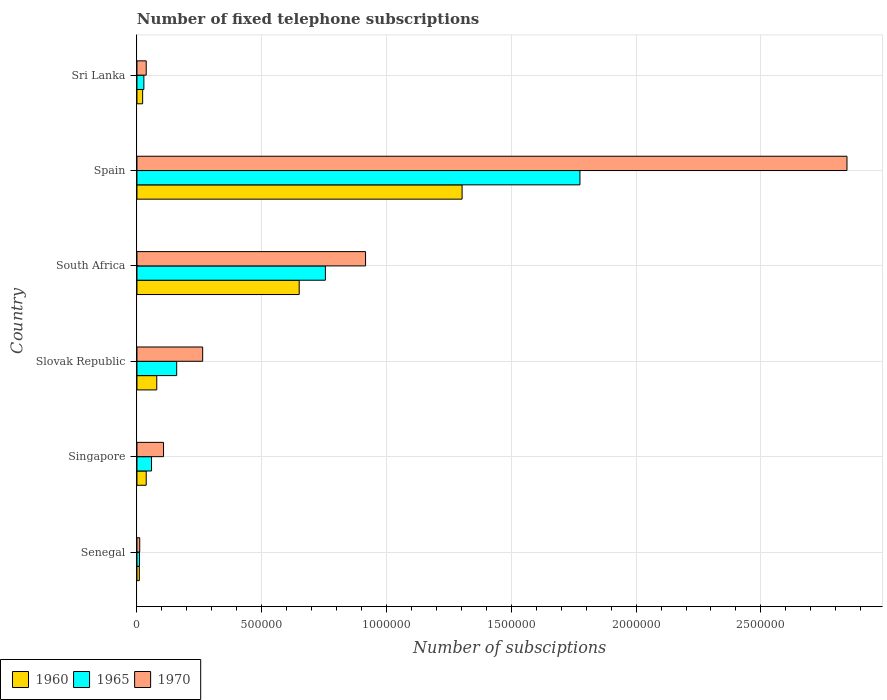How many different coloured bars are there?
Provide a succinct answer. 3. How many bars are there on the 3rd tick from the bottom?
Offer a very short reply. 3. What is the label of the 5th group of bars from the top?
Give a very brief answer. Singapore. What is the number of fixed telephone subscriptions in 1965 in Sri Lanka?
Provide a succinct answer. 2.77e+04. Across all countries, what is the maximum number of fixed telephone subscriptions in 1970?
Give a very brief answer. 2.84e+06. Across all countries, what is the minimum number of fixed telephone subscriptions in 1970?
Your answer should be compact. 1.10e+04. In which country was the number of fixed telephone subscriptions in 1960 minimum?
Give a very brief answer. Senegal. What is the total number of fixed telephone subscriptions in 1960 in the graph?
Ensure brevity in your answer.  2.10e+06. What is the difference between the number of fixed telephone subscriptions in 1970 in Singapore and that in Spain?
Ensure brevity in your answer.  -2.74e+06. What is the difference between the number of fixed telephone subscriptions in 1960 in Slovak Republic and the number of fixed telephone subscriptions in 1965 in Senegal?
Your answer should be very brief. 6.93e+04. What is the average number of fixed telephone subscriptions in 1965 per country?
Make the answer very short. 4.64e+05. What is the difference between the number of fixed telephone subscriptions in 1965 and number of fixed telephone subscriptions in 1970 in Slovak Republic?
Provide a short and direct response. -1.04e+05. What is the ratio of the number of fixed telephone subscriptions in 1970 in Singapore to that in Sri Lanka?
Ensure brevity in your answer.  2.87. Is the difference between the number of fixed telephone subscriptions in 1965 in South Africa and Sri Lanka greater than the difference between the number of fixed telephone subscriptions in 1970 in South Africa and Sri Lanka?
Provide a succinct answer. No. What is the difference between the highest and the second highest number of fixed telephone subscriptions in 1965?
Provide a short and direct response. 1.02e+06. What is the difference between the highest and the lowest number of fixed telephone subscriptions in 1960?
Your response must be concise. 1.29e+06. What does the 3rd bar from the top in Sri Lanka represents?
Offer a terse response. 1960. What does the 2nd bar from the bottom in Senegal represents?
Provide a short and direct response. 1965. How many countries are there in the graph?
Your response must be concise. 6. Does the graph contain any zero values?
Provide a succinct answer. No. Does the graph contain grids?
Offer a terse response. Yes. How many legend labels are there?
Your answer should be compact. 3. What is the title of the graph?
Offer a very short reply. Number of fixed telephone subscriptions. What is the label or title of the X-axis?
Offer a very short reply. Number of subsciptions. What is the label or title of the Y-axis?
Ensure brevity in your answer.  Country. What is the Number of subsciptions of 1960 in Senegal?
Give a very brief answer. 9494. What is the Number of subsciptions of 1965 in Senegal?
Your response must be concise. 10000. What is the Number of subsciptions in 1970 in Senegal?
Offer a terse response. 1.10e+04. What is the Number of subsciptions in 1960 in Singapore?
Your answer should be very brief. 3.71e+04. What is the Number of subsciptions in 1965 in Singapore?
Provide a short and direct response. 5.84e+04. What is the Number of subsciptions in 1970 in Singapore?
Offer a terse response. 1.06e+05. What is the Number of subsciptions in 1960 in Slovak Republic?
Give a very brief answer. 7.93e+04. What is the Number of subsciptions of 1965 in Slovak Republic?
Offer a terse response. 1.59e+05. What is the Number of subsciptions of 1970 in Slovak Republic?
Your answer should be compact. 2.63e+05. What is the Number of subsciptions of 1960 in South Africa?
Keep it short and to the point. 6.50e+05. What is the Number of subsciptions in 1965 in South Africa?
Ensure brevity in your answer.  7.55e+05. What is the Number of subsciptions of 1970 in South Africa?
Make the answer very short. 9.16e+05. What is the Number of subsciptions of 1960 in Spain?
Offer a very short reply. 1.30e+06. What is the Number of subsciptions in 1965 in Spain?
Ensure brevity in your answer.  1.78e+06. What is the Number of subsciptions of 1970 in Spain?
Make the answer very short. 2.84e+06. What is the Number of subsciptions of 1960 in Sri Lanka?
Provide a short and direct response. 2.28e+04. What is the Number of subsciptions of 1965 in Sri Lanka?
Make the answer very short. 2.77e+04. What is the Number of subsciptions in 1970 in Sri Lanka?
Ensure brevity in your answer.  3.71e+04. Across all countries, what is the maximum Number of subsciptions in 1960?
Make the answer very short. 1.30e+06. Across all countries, what is the maximum Number of subsciptions in 1965?
Your response must be concise. 1.78e+06. Across all countries, what is the maximum Number of subsciptions of 1970?
Your answer should be very brief. 2.84e+06. Across all countries, what is the minimum Number of subsciptions of 1960?
Your answer should be compact. 9494. Across all countries, what is the minimum Number of subsciptions of 1965?
Keep it short and to the point. 10000. Across all countries, what is the minimum Number of subsciptions in 1970?
Offer a terse response. 1.10e+04. What is the total Number of subsciptions in 1960 in the graph?
Offer a very short reply. 2.10e+06. What is the total Number of subsciptions in 1965 in the graph?
Your answer should be compact. 2.79e+06. What is the total Number of subsciptions in 1970 in the graph?
Make the answer very short. 4.18e+06. What is the difference between the Number of subsciptions of 1960 in Senegal and that in Singapore?
Make the answer very short. -2.76e+04. What is the difference between the Number of subsciptions of 1965 in Senegal and that in Singapore?
Offer a very short reply. -4.84e+04. What is the difference between the Number of subsciptions in 1970 in Senegal and that in Singapore?
Give a very brief answer. -9.54e+04. What is the difference between the Number of subsciptions of 1960 in Senegal and that in Slovak Republic?
Your answer should be very brief. -6.98e+04. What is the difference between the Number of subsciptions in 1965 in Senegal and that in Slovak Republic?
Give a very brief answer. -1.49e+05. What is the difference between the Number of subsciptions of 1970 in Senegal and that in Slovak Republic?
Your answer should be very brief. -2.52e+05. What is the difference between the Number of subsciptions of 1960 in Senegal and that in South Africa?
Give a very brief answer. -6.41e+05. What is the difference between the Number of subsciptions of 1965 in Senegal and that in South Africa?
Your answer should be compact. -7.45e+05. What is the difference between the Number of subsciptions of 1970 in Senegal and that in South Africa?
Provide a short and direct response. -9.05e+05. What is the difference between the Number of subsciptions in 1960 in Senegal and that in Spain?
Your response must be concise. -1.29e+06. What is the difference between the Number of subsciptions in 1965 in Senegal and that in Spain?
Offer a terse response. -1.76e+06. What is the difference between the Number of subsciptions of 1970 in Senegal and that in Spain?
Provide a short and direct response. -2.83e+06. What is the difference between the Number of subsciptions in 1960 in Senegal and that in Sri Lanka?
Give a very brief answer. -1.33e+04. What is the difference between the Number of subsciptions of 1965 in Senegal and that in Sri Lanka?
Your answer should be compact. -1.77e+04. What is the difference between the Number of subsciptions of 1970 in Senegal and that in Sri Lanka?
Provide a succinct answer. -2.61e+04. What is the difference between the Number of subsciptions in 1960 in Singapore and that in Slovak Republic?
Provide a succinct answer. -4.22e+04. What is the difference between the Number of subsciptions in 1965 in Singapore and that in Slovak Republic?
Offer a terse response. -1.01e+05. What is the difference between the Number of subsciptions of 1970 in Singapore and that in Slovak Republic?
Provide a succinct answer. -1.57e+05. What is the difference between the Number of subsciptions of 1960 in Singapore and that in South Africa?
Keep it short and to the point. -6.13e+05. What is the difference between the Number of subsciptions of 1965 in Singapore and that in South Africa?
Offer a terse response. -6.97e+05. What is the difference between the Number of subsciptions of 1970 in Singapore and that in South Africa?
Your answer should be very brief. -8.10e+05. What is the difference between the Number of subsciptions of 1960 in Singapore and that in Spain?
Provide a short and direct response. -1.27e+06. What is the difference between the Number of subsciptions in 1965 in Singapore and that in Spain?
Make the answer very short. -1.72e+06. What is the difference between the Number of subsciptions of 1970 in Singapore and that in Spain?
Provide a succinct answer. -2.74e+06. What is the difference between the Number of subsciptions of 1960 in Singapore and that in Sri Lanka?
Provide a succinct answer. 1.43e+04. What is the difference between the Number of subsciptions of 1965 in Singapore and that in Sri Lanka?
Keep it short and to the point. 3.07e+04. What is the difference between the Number of subsciptions in 1970 in Singapore and that in Sri Lanka?
Give a very brief answer. 6.93e+04. What is the difference between the Number of subsciptions of 1960 in Slovak Republic and that in South Africa?
Provide a short and direct response. -5.71e+05. What is the difference between the Number of subsciptions in 1965 in Slovak Republic and that in South Africa?
Your answer should be compact. -5.96e+05. What is the difference between the Number of subsciptions of 1970 in Slovak Republic and that in South Africa?
Your answer should be compact. -6.53e+05. What is the difference between the Number of subsciptions in 1960 in Slovak Republic and that in Spain?
Provide a succinct answer. -1.22e+06. What is the difference between the Number of subsciptions of 1965 in Slovak Republic and that in Spain?
Provide a succinct answer. -1.62e+06. What is the difference between the Number of subsciptions of 1970 in Slovak Republic and that in Spain?
Your answer should be compact. -2.58e+06. What is the difference between the Number of subsciptions of 1960 in Slovak Republic and that in Sri Lanka?
Ensure brevity in your answer.  5.66e+04. What is the difference between the Number of subsciptions in 1965 in Slovak Republic and that in Sri Lanka?
Your answer should be very brief. 1.32e+05. What is the difference between the Number of subsciptions in 1970 in Slovak Republic and that in Sri Lanka?
Offer a very short reply. 2.26e+05. What is the difference between the Number of subsciptions in 1960 in South Africa and that in Spain?
Ensure brevity in your answer.  -6.53e+05. What is the difference between the Number of subsciptions in 1965 in South Africa and that in Spain?
Your response must be concise. -1.02e+06. What is the difference between the Number of subsciptions in 1970 in South Africa and that in Spain?
Your response must be concise. -1.93e+06. What is the difference between the Number of subsciptions of 1960 in South Africa and that in Sri Lanka?
Your answer should be compact. 6.27e+05. What is the difference between the Number of subsciptions of 1965 in South Africa and that in Sri Lanka?
Your answer should be very brief. 7.27e+05. What is the difference between the Number of subsciptions in 1970 in South Africa and that in Sri Lanka?
Provide a succinct answer. 8.79e+05. What is the difference between the Number of subsciptions of 1960 in Spain and that in Sri Lanka?
Provide a succinct answer. 1.28e+06. What is the difference between the Number of subsciptions in 1965 in Spain and that in Sri Lanka?
Offer a very short reply. 1.75e+06. What is the difference between the Number of subsciptions of 1970 in Spain and that in Sri Lanka?
Your answer should be compact. 2.81e+06. What is the difference between the Number of subsciptions of 1960 in Senegal and the Number of subsciptions of 1965 in Singapore?
Your answer should be compact. -4.89e+04. What is the difference between the Number of subsciptions in 1960 in Senegal and the Number of subsciptions in 1970 in Singapore?
Give a very brief answer. -9.69e+04. What is the difference between the Number of subsciptions of 1965 in Senegal and the Number of subsciptions of 1970 in Singapore?
Make the answer very short. -9.64e+04. What is the difference between the Number of subsciptions in 1960 in Senegal and the Number of subsciptions in 1965 in Slovak Republic?
Provide a succinct answer. -1.50e+05. What is the difference between the Number of subsciptions in 1960 in Senegal and the Number of subsciptions in 1970 in Slovak Republic?
Keep it short and to the point. -2.54e+05. What is the difference between the Number of subsciptions of 1965 in Senegal and the Number of subsciptions of 1970 in Slovak Republic?
Your answer should be very brief. -2.53e+05. What is the difference between the Number of subsciptions in 1960 in Senegal and the Number of subsciptions in 1965 in South Africa?
Ensure brevity in your answer.  -7.46e+05. What is the difference between the Number of subsciptions of 1960 in Senegal and the Number of subsciptions of 1970 in South Africa?
Your answer should be compact. -9.07e+05. What is the difference between the Number of subsciptions in 1965 in Senegal and the Number of subsciptions in 1970 in South Africa?
Provide a short and direct response. -9.06e+05. What is the difference between the Number of subsciptions in 1960 in Senegal and the Number of subsciptions in 1965 in Spain?
Your answer should be compact. -1.77e+06. What is the difference between the Number of subsciptions in 1960 in Senegal and the Number of subsciptions in 1970 in Spain?
Provide a succinct answer. -2.84e+06. What is the difference between the Number of subsciptions of 1965 in Senegal and the Number of subsciptions of 1970 in Spain?
Provide a succinct answer. -2.84e+06. What is the difference between the Number of subsciptions of 1960 in Senegal and the Number of subsciptions of 1965 in Sri Lanka?
Your response must be concise. -1.82e+04. What is the difference between the Number of subsciptions of 1960 in Senegal and the Number of subsciptions of 1970 in Sri Lanka?
Your response must be concise. -2.76e+04. What is the difference between the Number of subsciptions of 1965 in Senegal and the Number of subsciptions of 1970 in Sri Lanka?
Your answer should be compact. -2.71e+04. What is the difference between the Number of subsciptions of 1960 in Singapore and the Number of subsciptions of 1965 in Slovak Republic?
Give a very brief answer. -1.22e+05. What is the difference between the Number of subsciptions in 1960 in Singapore and the Number of subsciptions in 1970 in Slovak Republic?
Keep it short and to the point. -2.26e+05. What is the difference between the Number of subsciptions in 1965 in Singapore and the Number of subsciptions in 1970 in Slovak Republic?
Provide a short and direct response. -2.05e+05. What is the difference between the Number of subsciptions in 1960 in Singapore and the Number of subsciptions in 1965 in South Africa?
Offer a very short reply. -7.18e+05. What is the difference between the Number of subsciptions of 1960 in Singapore and the Number of subsciptions of 1970 in South Africa?
Your answer should be compact. -8.79e+05. What is the difference between the Number of subsciptions of 1965 in Singapore and the Number of subsciptions of 1970 in South Africa?
Your answer should be very brief. -8.58e+05. What is the difference between the Number of subsciptions in 1960 in Singapore and the Number of subsciptions in 1965 in Spain?
Ensure brevity in your answer.  -1.74e+06. What is the difference between the Number of subsciptions of 1960 in Singapore and the Number of subsciptions of 1970 in Spain?
Provide a succinct answer. -2.81e+06. What is the difference between the Number of subsciptions of 1965 in Singapore and the Number of subsciptions of 1970 in Spain?
Your answer should be compact. -2.79e+06. What is the difference between the Number of subsciptions of 1960 in Singapore and the Number of subsciptions of 1965 in Sri Lanka?
Provide a succinct answer. 9413. What is the difference between the Number of subsciptions of 1960 in Singapore and the Number of subsciptions of 1970 in Sri Lanka?
Your response must be concise. 13. What is the difference between the Number of subsciptions in 1965 in Singapore and the Number of subsciptions in 1970 in Sri Lanka?
Provide a succinct answer. 2.13e+04. What is the difference between the Number of subsciptions in 1960 in Slovak Republic and the Number of subsciptions in 1965 in South Africa?
Keep it short and to the point. -6.76e+05. What is the difference between the Number of subsciptions in 1960 in Slovak Republic and the Number of subsciptions in 1970 in South Africa?
Keep it short and to the point. -8.37e+05. What is the difference between the Number of subsciptions of 1965 in Slovak Republic and the Number of subsciptions of 1970 in South Africa?
Offer a very short reply. -7.57e+05. What is the difference between the Number of subsciptions in 1960 in Slovak Republic and the Number of subsciptions in 1965 in Spain?
Ensure brevity in your answer.  -1.70e+06. What is the difference between the Number of subsciptions in 1960 in Slovak Republic and the Number of subsciptions in 1970 in Spain?
Offer a very short reply. -2.77e+06. What is the difference between the Number of subsciptions in 1965 in Slovak Republic and the Number of subsciptions in 1970 in Spain?
Ensure brevity in your answer.  -2.69e+06. What is the difference between the Number of subsciptions in 1960 in Slovak Republic and the Number of subsciptions in 1965 in Sri Lanka?
Ensure brevity in your answer.  5.16e+04. What is the difference between the Number of subsciptions in 1960 in Slovak Republic and the Number of subsciptions in 1970 in Sri Lanka?
Give a very brief answer. 4.22e+04. What is the difference between the Number of subsciptions of 1965 in Slovak Republic and the Number of subsciptions of 1970 in Sri Lanka?
Provide a succinct answer. 1.22e+05. What is the difference between the Number of subsciptions of 1960 in South Africa and the Number of subsciptions of 1965 in Spain?
Provide a short and direct response. -1.12e+06. What is the difference between the Number of subsciptions of 1960 in South Africa and the Number of subsciptions of 1970 in Spain?
Your answer should be very brief. -2.19e+06. What is the difference between the Number of subsciptions in 1965 in South Africa and the Number of subsciptions in 1970 in Spain?
Give a very brief answer. -2.09e+06. What is the difference between the Number of subsciptions of 1960 in South Africa and the Number of subsciptions of 1965 in Sri Lanka?
Make the answer very short. 6.22e+05. What is the difference between the Number of subsciptions of 1960 in South Africa and the Number of subsciptions of 1970 in Sri Lanka?
Your answer should be very brief. 6.13e+05. What is the difference between the Number of subsciptions in 1965 in South Africa and the Number of subsciptions in 1970 in Sri Lanka?
Give a very brief answer. 7.18e+05. What is the difference between the Number of subsciptions in 1960 in Spain and the Number of subsciptions in 1965 in Sri Lanka?
Ensure brevity in your answer.  1.28e+06. What is the difference between the Number of subsciptions of 1960 in Spain and the Number of subsciptions of 1970 in Sri Lanka?
Provide a short and direct response. 1.27e+06. What is the difference between the Number of subsciptions in 1965 in Spain and the Number of subsciptions in 1970 in Sri Lanka?
Offer a terse response. 1.74e+06. What is the average Number of subsciptions in 1960 per country?
Your answer should be very brief. 3.50e+05. What is the average Number of subsciptions in 1965 per country?
Your response must be concise. 4.64e+05. What is the average Number of subsciptions of 1970 per country?
Provide a short and direct response. 6.96e+05. What is the difference between the Number of subsciptions of 1960 and Number of subsciptions of 1965 in Senegal?
Offer a very short reply. -506. What is the difference between the Number of subsciptions in 1960 and Number of subsciptions in 1970 in Senegal?
Provide a short and direct response. -1544. What is the difference between the Number of subsciptions in 1965 and Number of subsciptions in 1970 in Senegal?
Provide a succinct answer. -1038. What is the difference between the Number of subsciptions in 1960 and Number of subsciptions in 1965 in Singapore?
Ensure brevity in your answer.  -2.13e+04. What is the difference between the Number of subsciptions of 1960 and Number of subsciptions of 1970 in Singapore?
Provide a short and direct response. -6.93e+04. What is the difference between the Number of subsciptions of 1965 and Number of subsciptions of 1970 in Singapore?
Provide a succinct answer. -4.81e+04. What is the difference between the Number of subsciptions in 1960 and Number of subsciptions in 1965 in Slovak Republic?
Give a very brief answer. -7.99e+04. What is the difference between the Number of subsciptions of 1960 and Number of subsciptions of 1970 in Slovak Republic?
Ensure brevity in your answer.  -1.84e+05. What is the difference between the Number of subsciptions in 1965 and Number of subsciptions in 1970 in Slovak Republic?
Keep it short and to the point. -1.04e+05. What is the difference between the Number of subsciptions in 1960 and Number of subsciptions in 1965 in South Africa?
Provide a succinct answer. -1.05e+05. What is the difference between the Number of subsciptions in 1960 and Number of subsciptions in 1970 in South Africa?
Provide a short and direct response. -2.66e+05. What is the difference between the Number of subsciptions of 1965 and Number of subsciptions of 1970 in South Africa?
Make the answer very short. -1.61e+05. What is the difference between the Number of subsciptions of 1960 and Number of subsciptions of 1965 in Spain?
Give a very brief answer. -4.72e+05. What is the difference between the Number of subsciptions in 1960 and Number of subsciptions in 1970 in Spain?
Give a very brief answer. -1.54e+06. What is the difference between the Number of subsciptions in 1965 and Number of subsciptions in 1970 in Spain?
Your response must be concise. -1.07e+06. What is the difference between the Number of subsciptions of 1960 and Number of subsciptions of 1965 in Sri Lanka?
Provide a short and direct response. -4928. What is the difference between the Number of subsciptions of 1960 and Number of subsciptions of 1970 in Sri Lanka?
Make the answer very short. -1.43e+04. What is the difference between the Number of subsciptions of 1965 and Number of subsciptions of 1970 in Sri Lanka?
Ensure brevity in your answer.  -9400. What is the ratio of the Number of subsciptions of 1960 in Senegal to that in Singapore?
Give a very brief answer. 0.26. What is the ratio of the Number of subsciptions of 1965 in Senegal to that in Singapore?
Provide a short and direct response. 0.17. What is the ratio of the Number of subsciptions in 1970 in Senegal to that in Singapore?
Your answer should be compact. 0.1. What is the ratio of the Number of subsciptions of 1960 in Senegal to that in Slovak Republic?
Your response must be concise. 0.12. What is the ratio of the Number of subsciptions in 1965 in Senegal to that in Slovak Republic?
Keep it short and to the point. 0.06. What is the ratio of the Number of subsciptions in 1970 in Senegal to that in Slovak Republic?
Provide a short and direct response. 0.04. What is the ratio of the Number of subsciptions of 1960 in Senegal to that in South Africa?
Provide a succinct answer. 0.01. What is the ratio of the Number of subsciptions of 1965 in Senegal to that in South Africa?
Offer a very short reply. 0.01. What is the ratio of the Number of subsciptions of 1970 in Senegal to that in South Africa?
Offer a very short reply. 0.01. What is the ratio of the Number of subsciptions in 1960 in Senegal to that in Spain?
Offer a terse response. 0.01. What is the ratio of the Number of subsciptions in 1965 in Senegal to that in Spain?
Your answer should be compact. 0.01. What is the ratio of the Number of subsciptions of 1970 in Senegal to that in Spain?
Ensure brevity in your answer.  0. What is the ratio of the Number of subsciptions in 1960 in Senegal to that in Sri Lanka?
Offer a terse response. 0.42. What is the ratio of the Number of subsciptions in 1965 in Senegal to that in Sri Lanka?
Provide a succinct answer. 0.36. What is the ratio of the Number of subsciptions in 1970 in Senegal to that in Sri Lanka?
Offer a very short reply. 0.3. What is the ratio of the Number of subsciptions of 1960 in Singapore to that in Slovak Republic?
Ensure brevity in your answer.  0.47. What is the ratio of the Number of subsciptions in 1965 in Singapore to that in Slovak Republic?
Keep it short and to the point. 0.37. What is the ratio of the Number of subsciptions in 1970 in Singapore to that in Slovak Republic?
Your answer should be very brief. 0.4. What is the ratio of the Number of subsciptions in 1960 in Singapore to that in South Africa?
Ensure brevity in your answer.  0.06. What is the ratio of the Number of subsciptions in 1965 in Singapore to that in South Africa?
Your answer should be very brief. 0.08. What is the ratio of the Number of subsciptions in 1970 in Singapore to that in South Africa?
Provide a short and direct response. 0.12. What is the ratio of the Number of subsciptions of 1960 in Singapore to that in Spain?
Keep it short and to the point. 0.03. What is the ratio of the Number of subsciptions in 1965 in Singapore to that in Spain?
Give a very brief answer. 0.03. What is the ratio of the Number of subsciptions in 1970 in Singapore to that in Spain?
Offer a very short reply. 0.04. What is the ratio of the Number of subsciptions in 1960 in Singapore to that in Sri Lanka?
Provide a short and direct response. 1.63. What is the ratio of the Number of subsciptions of 1965 in Singapore to that in Sri Lanka?
Keep it short and to the point. 2.11. What is the ratio of the Number of subsciptions in 1970 in Singapore to that in Sri Lanka?
Make the answer very short. 2.87. What is the ratio of the Number of subsciptions in 1960 in Slovak Republic to that in South Africa?
Keep it short and to the point. 0.12. What is the ratio of the Number of subsciptions of 1965 in Slovak Republic to that in South Africa?
Make the answer very short. 0.21. What is the ratio of the Number of subsciptions of 1970 in Slovak Republic to that in South Africa?
Keep it short and to the point. 0.29. What is the ratio of the Number of subsciptions in 1960 in Slovak Republic to that in Spain?
Offer a terse response. 0.06. What is the ratio of the Number of subsciptions of 1965 in Slovak Republic to that in Spain?
Provide a short and direct response. 0.09. What is the ratio of the Number of subsciptions in 1970 in Slovak Republic to that in Spain?
Ensure brevity in your answer.  0.09. What is the ratio of the Number of subsciptions of 1960 in Slovak Republic to that in Sri Lanka?
Your answer should be very brief. 3.48. What is the ratio of the Number of subsciptions in 1965 in Slovak Republic to that in Sri Lanka?
Offer a terse response. 5.75. What is the ratio of the Number of subsciptions in 1970 in Slovak Republic to that in Sri Lanka?
Offer a terse response. 7.1. What is the ratio of the Number of subsciptions in 1960 in South Africa to that in Spain?
Your answer should be compact. 0.5. What is the ratio of the Number of subsciptions of 1965 in South Africa to that in Spain?
Provide a short and direct response. 0.43. What is the ratio of the Number of subsciptions in 1970 in South Africa to that in Spain?
Ensure brevity in your answer.  0.32. What is the ratio of the Number of subsciptions in 1960 in South Africa to that in Sri Lanka?
Give a very brief answer. 28.54. What is the ratio of the Number of subsciptions in 1965 in South Africa to that in Sri Lanka?
Provide a succinct answer. 27.26. What is the ratio of the Number of subsciptions in 1970 in South Africa to that in Sri Lanka?
Keep it short and to the point. 24.69. What is the ratio of the Number of subsciptions of 1960 in Spain to that in Sri Lanka?
Provide a short and direct response. 57.21. What is the ratio of the Number of subsciptions in 1965 in Spain to that in Sri Lanka?
Offer a very short reply. 64.08. What is the ratio of the Number of subsciptions in 1970 in Spain to that in Sri Lanka?
Your answer should be very brief. 76.68. What is the difference between the highest and the second highest Number of subsciptions in 1960?
Your response must be concise. 6.53e+05. What is the difference between the highest and the second highest Number of subsciptions of 1965?
Keep it short and to the point. 1.02e+06. What is the difference between the highest and the second highest Number of subsciptions in 1970?
Provide a succinct answer. 1.93e+06. What is the difference between the highest and the lowest Number of subsciptions of 1960?
Give a very brief answer. 1.29e+06. What is the difference between the highest and the lowest Number of subsciptions in 1965?
Your answer should be very brief. 1.76e+06. What is the difference between the highest and the lowest Number of subsciptions in 1970?
Offer a terse response. 2.83e+06. 